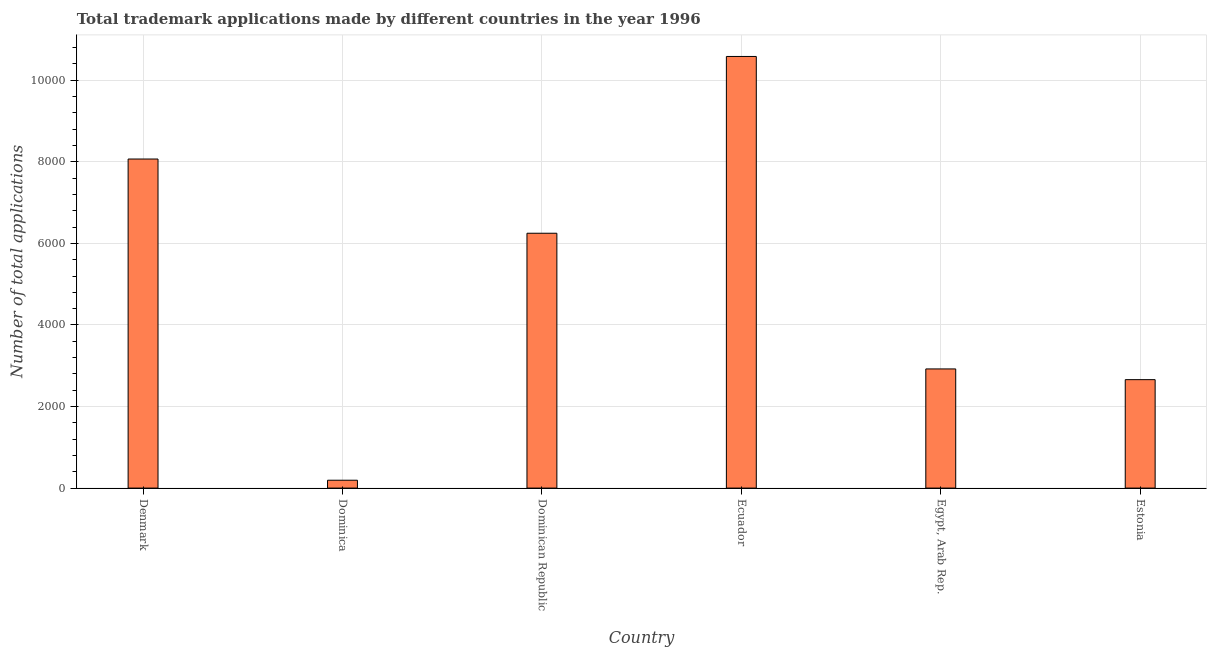Does the graph contain any zero values?
Keep it short and to the point. No. Does the graph contain grids?
Offer a very short reply. Yes. What is the title of the graph?
Provide a short and direct response. Total trademark applications made by different countries in the year 1996. What is the label or title of the Y-axis?
Provide a short and direct response. Number of total applications. What is the number of trademark applications in Dominican Republic?
Your response must be concise. 6249. Across all countries, what is the maximum number of trademark applications?
Give a very brief answer. 1.06e+04. Across all countries, what is the minimum number of trademark applications?
Keep it short and to the point. 193. In which country was the number of trademark applications maximum?
Your answer should be compact. Ecuador. In which country was the number of trademark applications minimum?
Your answer should be compact. Dominica. What is the sum of the number of trademark applications?
Your answer should be very brief. 3.07e+04. What is the difference between the number of trademark applications in Ecuador and Estonia?
Provide a succinct answer. 7925. What is the average number of trademark applications per country?
Your answer should be very brief. 5112. What is the median number of trademark applications?
Your answer should be compact. 4585.5. What is the ratio of the number of trademark applications in Denmark to that in Dominican Republic?
Provide a succinct answer. 1.29. Is the number of trademark applications in Denmark less than that in Ecuador?
Give a very brief answer. Yes. What is the difference between the highest and the second highest number of trademark applications?
Make the answer very short. 2515. What is the difference between the highest and the lowest number of trademark applications?
Your response must be concise. 1.04e+04. In how many countries, is the number of trademark applications greater than the average number of trademark applications taken over all countries?
Keep it short and to the point. 3. How many bars are there?
Provide a succinct answer. 6. What is the difference between two consecutive major ticks on the Y-axis?
Provide a short and direct response. 2000. What is the Number of total applications in Denmark?
Ensure brevity in your answer.  8069. What is the Number of total applications of Dominica?
Give a very brief answer. 193. What is the Number of total applications of Dominican Republic?
Offer a very short reply. 6249. What is the Number of total applications in Ecuador?
Your answer should be very brief. 1.06e+04. What is the Number of total applications in Egypt, Arab Rep.?
Provide a succinct answer. 2922. What is the Number of total applications in Estonia?
Your answer should be very brief. 2659. What is the difference between the Number of total applications in Denmark and Dominica?
Provide a succinct answer. 7876. What is the difference between the Number of total applications in Denmark and Dominican Republic?
Your answer should be very brief. 1820. What is the difference between the Number of total applications in Denmark and Ecuador?
Keep it short and to the point. -2515. What is the difference between the Number of total applications in Denmark and Egypt, Arab Rep.?
Give a very brief answer. 5147. What is the difference between the Number of total applications in Denmark and Estonia?
Give a very brief answer. 5410. What is the difference between the Number of total applications in Dominica and Dominican Republic?
Your response must be concise. -6056. What is the difference between the Number of total applications in Dominica and Ecuador?
Your answer should be very brief. -1.04e+04. What is the difference between the Number of total applications in Dominica and Egypt, Arab Rep.?
Keep it short and to the point. -2729. What is the difference between the Number of total applications in Dominica and Estonia?
Ensure brevity in your answer.  -2466. What is the difference between the Number of total applications in Dominican Republic and Ecuador?
Make the answer very short. -4335. What is the difference between the Number of total applications in Dominican Republic and Egypt, Arab Rep.?
Keep it short and to the point. 3327. What is the difference between the Number of total applications in Dominican Republic and Estonia?
Your response must be concise. 3590. What is the difference between the Number of total applications in Ecuador and Egypt, Arab Rep.?
Your answer should be compact. 7662. What is the difference between the Number of total applications in Ecuador and Estonia?
Offer a terse response. 7925. What is the difference between the Number of total applications in Egypt, Arab Rep. and Estonia?
Offer a terse response. 263. What is the ratio of the Number of total applications in Denmark to that in Dominica?
Provide a short and direct response. 41.81. What is the ratio of the Number of total applications in Denmark to that in Dominican Republic?
Provide a short and direct response. 1.29. What is the ratio of the Number of total applications in Denmark to that in Ecuador?
Provide a short and direct response. 0.76. What is the ratio of the Number of total applications in Denmark to that in Egypt, Arab Rep.?
Keep it short and to the point. 2.76. What is the ratio of the Number of total applications in Denmark to that in Estonia?
Your answer should be very brief. 3.04. What is the ratio of the Number of total applications in Dominica to that in Dominican Republic?
Ensure brevity in your answer.  0.03. What is the ratio of the Number of total applications in Dominica to that in Ecuador?
Give a very brief answer. 0.02. What is the ratio of the Number of total applications in Dominica to that in Egypt, Arab Rep.?
Make the answer very short. 0.07. What is the ratio of the Number of total applications in Dominica to that in Estonia?
Your response must be concise. 0.07. What is the ratio of the Number of total applications in Dominican Republic to that in Ecuador?
Make the answer very short. 0.59. What is the ratio of the Number of total applications in Dominican Republic to that in Egypt, Arab Rep.?
Provide a succinct answer. 2.14. What is the ratio of the Number of total applications in Dominican Republic to that in Estonia?
Your answer should be very brief. 2.35. What is the ratio of the Number of total applications in Ecuador to that in Egypt, Arab Rep.?
Keep it short and to the point. 3.62. What is the ratio of the Number of total applications in Ecuador to that in Estonia?
Keep it short and to the point. 3.98. What is the ratio of the Number of total applications in Egypt, Arab Rep. to that in Estonia?
Your answer should be very brief. 1.1. 